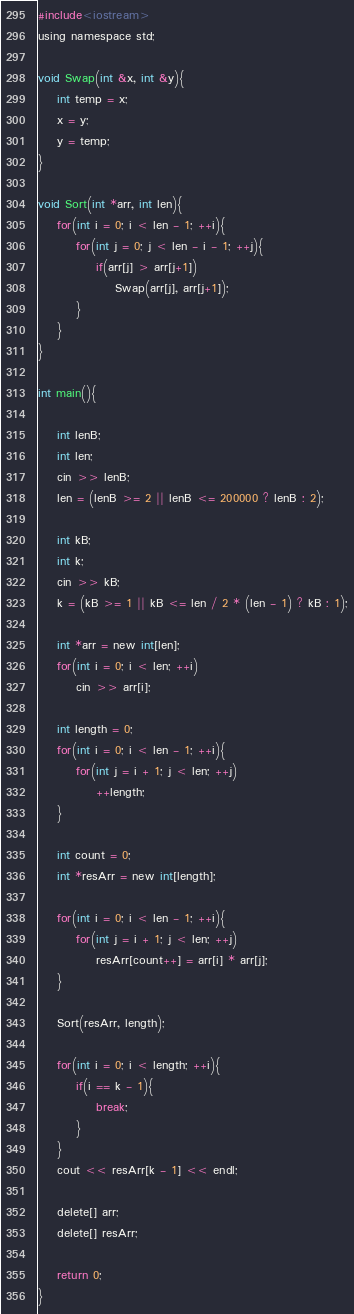<code> <loc_0><loc_0><loc_500><loc_500><_C_>#include<iostream>
using namespace std;

void Swap(int &x, int &y){
	int temp = x;
	x = y;
	y = temp;
}

void Sort(int *arr, int len){
	for(int i = 0; i < len - 1; ++i){
		for(int j = 0; j < len - i - 1; ++j){
			if(arr[j] > arr[j+1])
				Swap(arr[j], arr[j+1]);	
		}
	}
}

int main(){

	int lenB;
	int len;
	cin >> lenB;
	len = (lenB >= 2 || lenB <= 200000 ? lenB : 2);
	
	int kB;
	int k;
	cin >> kB;
	k = (kB >= 1 || kB <= len / 2 * (len - 1) ? kB : 1);

	int *arr = new int[len];
	for(int i = 0; i < len; ++i)
		cin >> arr[i];

	int length = 0;
	for(int i = 0; i < len - 1; ++i){
		for(int j = i + 1; j < len; ++j)
			++length;
	}

	int count = 0;
	int *resArr = new int[length];

	for(int i = 0; i < len - 1; ++i){
		for(int j = i + 1; j < len; ++j)
			resArr[count++] = arr[i] * arr[j];
	}

	Sort(resArr, length);

	for(int i = 0; i < length; ++i){
		if(i == k - 1){
			break;
		}
	}
	cout << resArr[k - 1] << endl;

	delete[] arr;
	delete[] resArr;

	return 0;
}</code> 